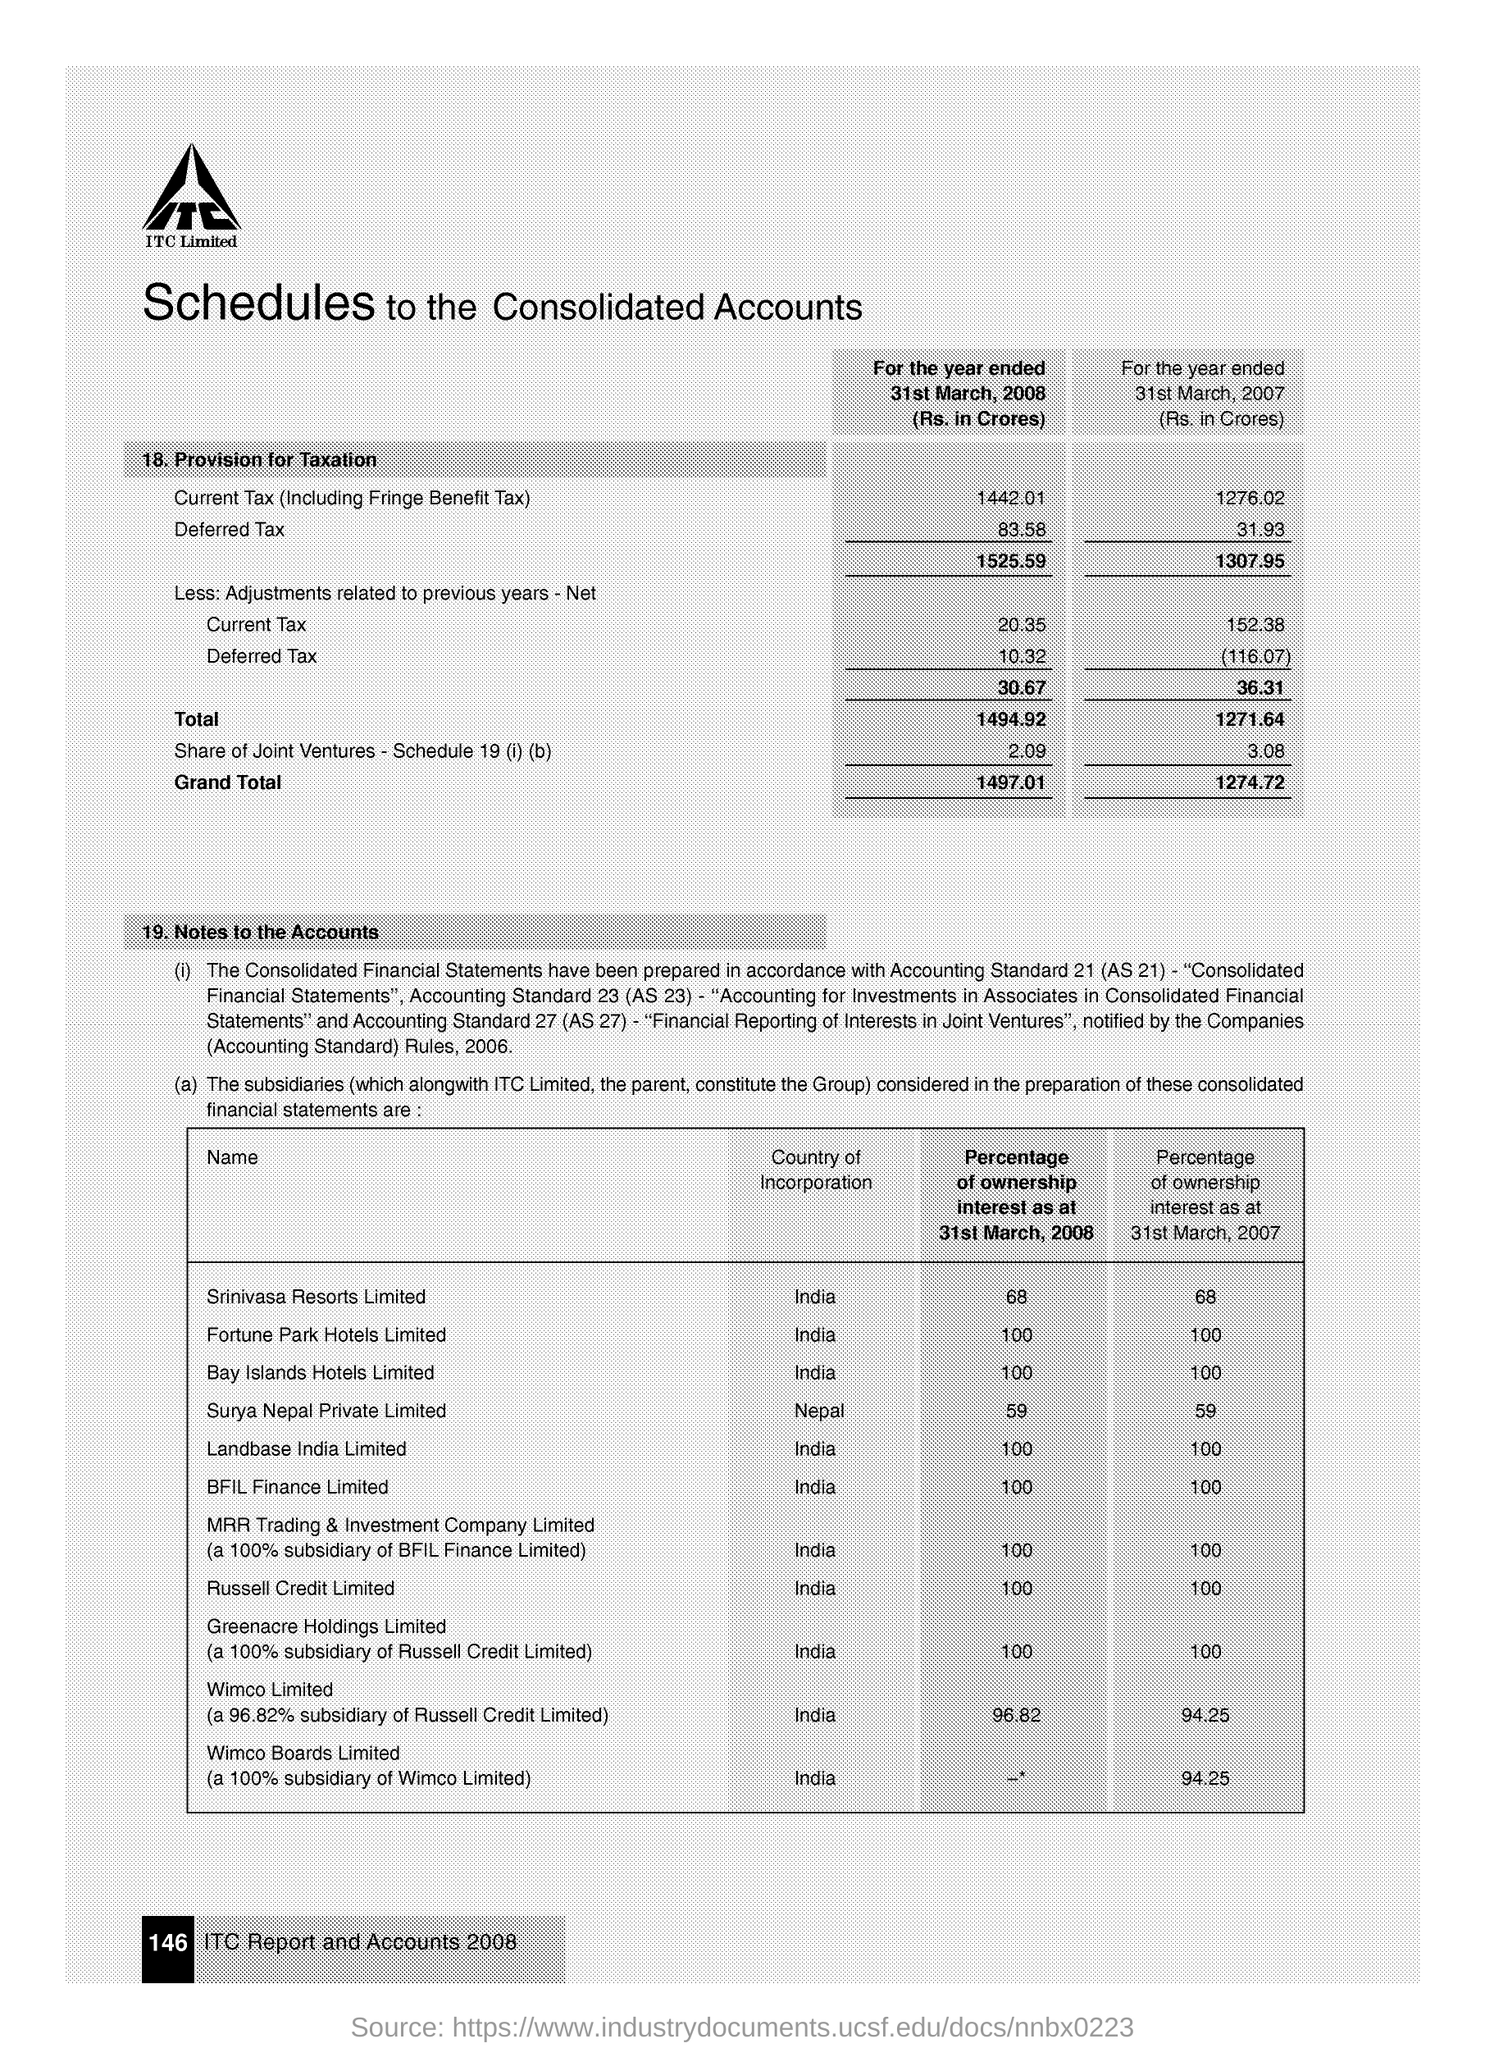Give some essential details in this illustration. The deferred tax for the year ended 31st March, 2008 was Rs. 83.58 crores. Srinivasa Resorts Limited is incorporated in India. 